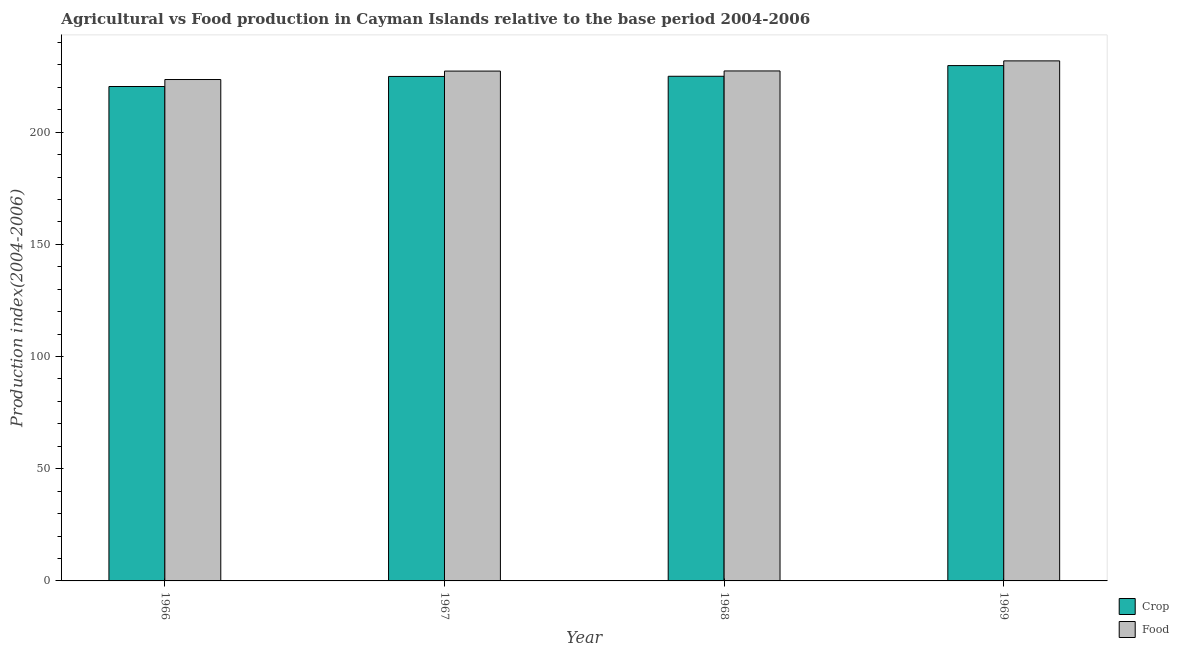How many different coloured bars are there?
Your response must be concise. 2. Are the number of bars per tick equal to the number of legend labels?
Offer a very short reply. Yes. How many bars are there on the 2nd tick from the left?
Provide a short and direct response. 2. What is the label of the 1st group of bars from the left?
Your answer should be compact. 1966. In how many cases, is the number of bars for a given year not equal to the number of legend labels?
Offer a terse response. 0. What is the crop production index in 1969?
Give a very brief answer. 229.68. Across all years, what is the maximum crop production index?
Keep it short and to the point. 229.68. Across all years, what is the minimum food production index?
Your answer should be compact. 223.47. In which year was the crop production index maximum?
Your answer should be compact. 1969. In which year was the crop production index minimum?
Offer a terse response. 1966. What is the total food production index in the graph?
Offer a terse response. 909.77. What is the difference between the food production index in 1966 and that in 1969?
Make the answer very short. -8.31. What is the difference between the food production index in 1966 and the crop production index in 1968?
Provide a succinct answer. -3.82. What is the average food production index per year?
Provide a succinct answer. 227.44. In the year 1966, what is the difference between the crop production index and food production index?
Offer a terse response. 0. In how many years, is the food production index greater than 150?
Offer a terse response. 4. What is the ratio of the food production index in 1968 to that in 1969?
Provide a succinct answer. 0.98. Is the food production index in 1968 less than that in 1969?
Make the answer very short. Yes. What is the difference between the highest and the second highest food production index?
Provide a succinct answer. 4.49. What is the difference between the highest and the lowest food production index?
Offer a terse response. 8.31. Is the sum of the food production index in 1968 and 1969 greater than the maximum crop production index across all years?
Offer a terse response. Yes. What does the 2nd bar from the left in 1968 represents?
Offer a terse response. Food. What does the 2nd bar from the right in 1966 represents?
Your answer should be compact. Crop. How many bars are there?
Offer a very short reply. 8. Are all the bars in the graph horizontal?
Offer a terse response. No. Does the graph contain any zero values?
Provide a succinct answer. No. Does the graph contain grids?
Provide a short and direct response. No. What is the title of the graph?
Ensure brevity in your answer.  Agricultural vs Food production in Cayman Islands relative to the base period 2004-2006. What is the label or title of the X-axis?
Provide a succinct answer. Year. What is the label or title of the Y-axis?
Offer a very short reply. Production index(2004-2006). What is the Production index(2004-2006) in Crop in 1966?
Provide a succinct answer. 220.36. What is the Production index(2004-2006) of Food in 1966?
Offer a very short reply. 223.47. What is the Production index(2004-2006) in Crop in 1967?
Ensure brevity in your answer.  224.84. What is the Production index(2004-2006) in Food in 1967?
Keep it short and to the point. 227.23. What is the Production index(2004-2006) in Crop in 1968?
Offer a very short reply. 224.92. What is the Production index(2004-2006) in Food in 1968?
Provide a succinct answer. 227.29. What is the Production index(2004-2006) of Crop in 1969?
Provide a succinct answer. 229.68. What is the Production index(2004-2006) of Food in 1969?
Give a very brief answer. 231.78. Across all years, what is the maximum Production index(2004-2006) of Crop?
Give a very brief answer. 229.68. Across all years, what is the maximum Production index(2004-2006) in Food?
Provide a short and direct response. 231.78. Across all years, what is the minimum Production index(2004-2006) of Crop?
Your answer should be very brief. 220.36. Across all years, what is the minimum Production index(2004-2006) in Food?
Keep it short and to the point. 223.47. What is the total Production index(2004-2006) in Crop in the graph?
Give a very brief answer. 899.8. What is the total Production index(2004-2006) of Food in the graph?
Your answer should be compact. 909.77. What is the difference between the Production index(2004-2006) in Crop in 1966 and that in 1967?
Offer a terse response. -4.48. What is the difference between the Production index(2004-2006) in Food in 1966 and that in 1967?
Offer a terse response. -3.76. What is the difference between the Production index(2004-2006) in Crop in 1966 and that in 1968?
Ensure brevity in your answer.  -4.56. What is the difference between the Production index(2004-2006) in Food in 1966 and that in 1968?
Offer a terse response. -3.82. What is the difference between the Production index(2004-2006) of Crop in 1966 and that in 1969?
Your response must be concise. -9.32. What is the difference between the Production index(2004-2006) of Food in 1966 and that in 1969?
Offer a terse response. -8.31. What is the difference between the Production index(2004-2006) of Crop in 1967 and that in 1968?
Your response must be concise. -0.08. What is the difference between the Production index(2004-2006) of Food in 1967 and that in 1968?
Your answer should be compact. -0.06. What is the difference between the Production index(2004-2006) in Crop in 1967 and that in 1969?
Your answer should be compact. -4.84. What is the difference between the Production index(2004-2006) of Food in 1967 and that in 1969?
Provide a short and direct response. -4.55. What is the difference between the Production index(2004-2006) in Crop in 1968 and that in 1969?
Keep it short and to the point. -4.76. What is the difference between the Production index(2004-2006) in Food in 1968 and that in 1969?
Keep it short and to the point. -4.49. What is the difference between the Production index(2004-2006) in Crop in 1966 and the Production index(2004-2006) in Food in 1967?
Offer a terse response. -6.87. What is the difference between the Production index(2004-2006) in Crop in 1966 and the Production index(2004-2006) in Food in 1968?
Make the answer very short. -6.93. What is the difference between the Production index(2004-2006) of Crop in 1966 and the Production index(2004-2006) of Food in 1969?
Your response must be concise. -11.42. What is the difference between the Production index(2004-2006) of Crop in 1967 and the Production index(2004-2006) of Food in 1968?
Keep it short and to the point. -2.45. What is the difference between the Production index(2004-2006) of Crop in 1967 and the Production index(2004-2006) of Food in 1969?
Offer a very short reply. -6.94. What is the difference between the Production index(2004-2006) in Crop in 1968 and the Production index(2004-2006) in Food in 1969?
Provide a succinct answer. -6.86. What is the average Production index(2004-2006) in Crop per year?
Your answer should be compact. 224.95. What is the average Production index(2004-2006) in Food per year?
Provide a succinct answer. 227.44. In the year 1966, what is the difference between the Production index(2004-2006) in Crop and Production index(2004-2006) in Food?
Make the answer very short. -3.11. In the year 1967, what is the difference between the Production index(2004-2006) in Crop and Production index(2004-2006) in Food?
Ensure brevity in your answer.  -2.39. In the year 1968, what is the difference between the Production index(2004-2006) of Crop and Production index(2004-2006) of Food?
Your answer should be compact. -2.37. What is the ratio of the Production index(2004-2006) in Crop in 1966 to that in 1967?
Offer a very short reply. 0.98. What is the ratio of the Production index(2004-2006) in Food in 1966 to that in 1967?
Provide a short and direct response. 0.98. What is the ratio of the Production index(2004-2006) in Crop in 1966 to that in 1968?
Provide a succinct answer. 0.98. What is the ratio of the Production index(2004-2006) in Food in 1966 to that in 1968?
Make the answer very short. 0.98. What is the ratio of the Production index(2004-2006) of Crop in 1966 to that in 1969?
Keep it short and to the point. 0.96. What is the ratio of the Production index(2004-2006) of Food in 1966 to that in 1969?
Your answer should be compact. 0.96. What is the ratio of the Production index(2004-2006) in Crop in 1967 to that in 1969?
Ensure brevity in your answer.  0.98. What is the ratio of the Production index(2004-2006) of Food in 1967 to that in 1969?
Provide a succinct answer. 0.98. What is the ratio of the Production index(2004-2006) in Crop in 1968 to that in 1969?
Ensure brevity in your answer.  0.98. What is the ratio of the Production index(2004-2006) of Food in 1968 to that in 1969?
Your answer should be compact. 0.98. What is the difference between the highest and the second highest Production index(2004-2006) of Crop?
Your answer should be compact. 4.76. What is the difference between the highest and the second highest Production index(2004-2006) of Food?
Make the answer very short. 4.49. What is the difference between the highest and the lowest Production index(2004-2006) of Crop?
Your answer should be compact. 9.32. What is the difference between the highest and the lowest Production index(2004-2006) in Food?
Your response must be concise. 8.31. 